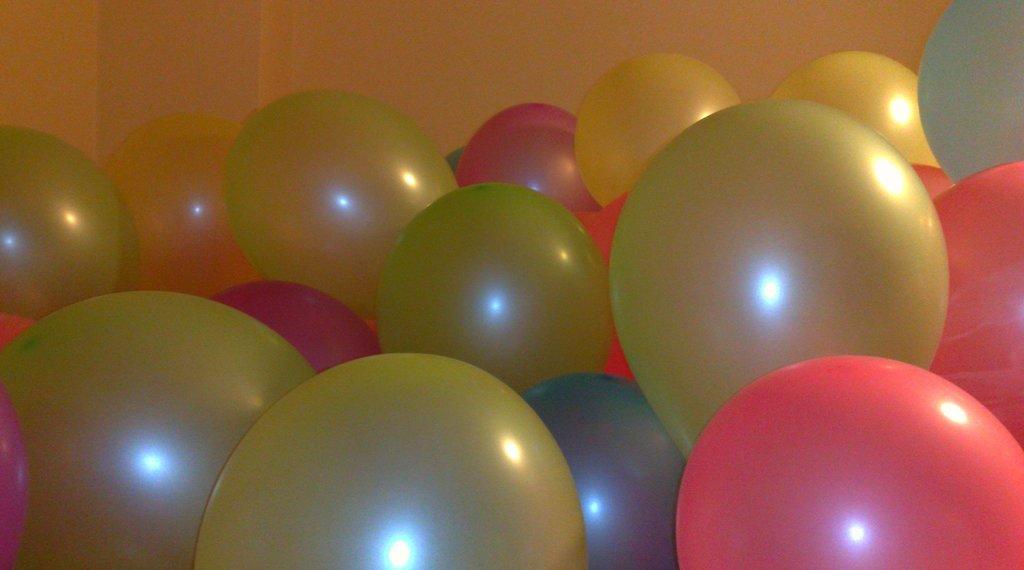Describe this image in one or two sentences. In this image we can see some different color balloons and in the background, we can see the wall. 